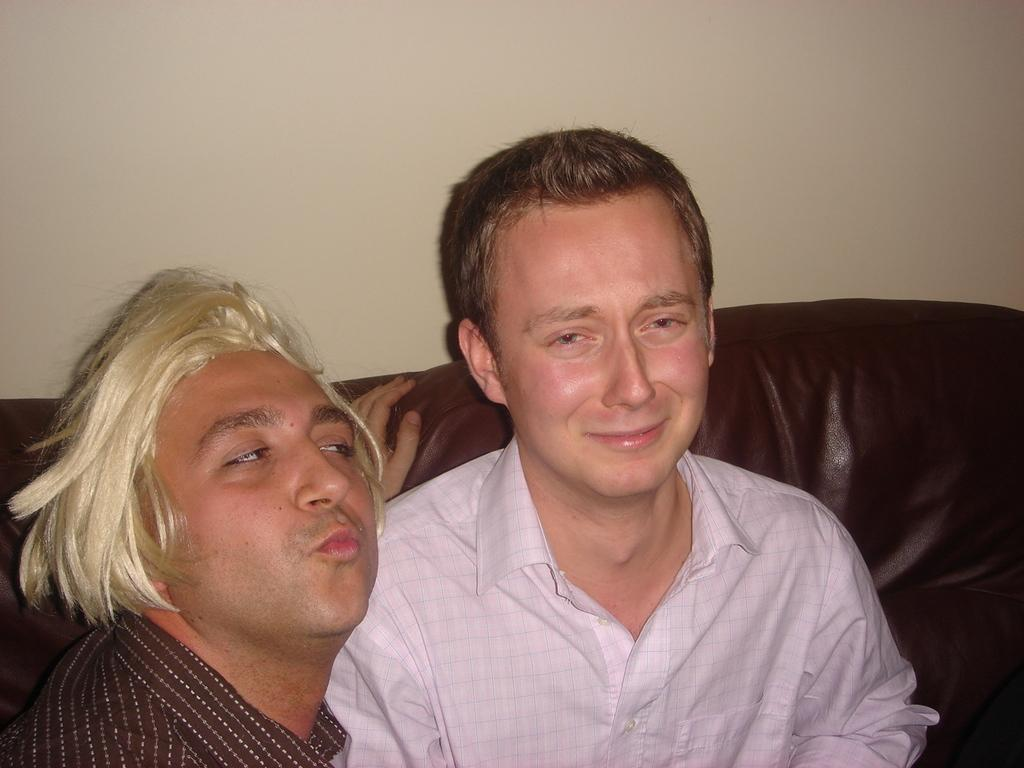How many people are in the image? There are two people in the image. Where are the two people located in the image? The two people are on the left side of the image. What are the two people wearing? The two people are wearing clothes. What type of furniture is in the image? There is a couch in the image. What is the background of the image? There is a wall in the image. What type of harmony can be heard in the image? There is no audible sound or music in the image, so it is not possible to determine if there is any harmony present. 